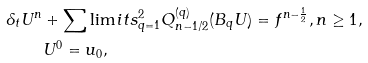<formula> <loc_0><loc_0><loc_500><loc_500>\delta _ { t } U ^ { n } & + \sum \lim i t s _ { q = 1 } ^ { 2 } Q _ { n - 1 / 2 } ^ { ( q ) } ( B _ { q } U ) = f ^ { n - \frac { 1 } { 2 } } , n \geq 1 , \\ & U ^ { 0 } = u _ { 0 } ,</formula> 